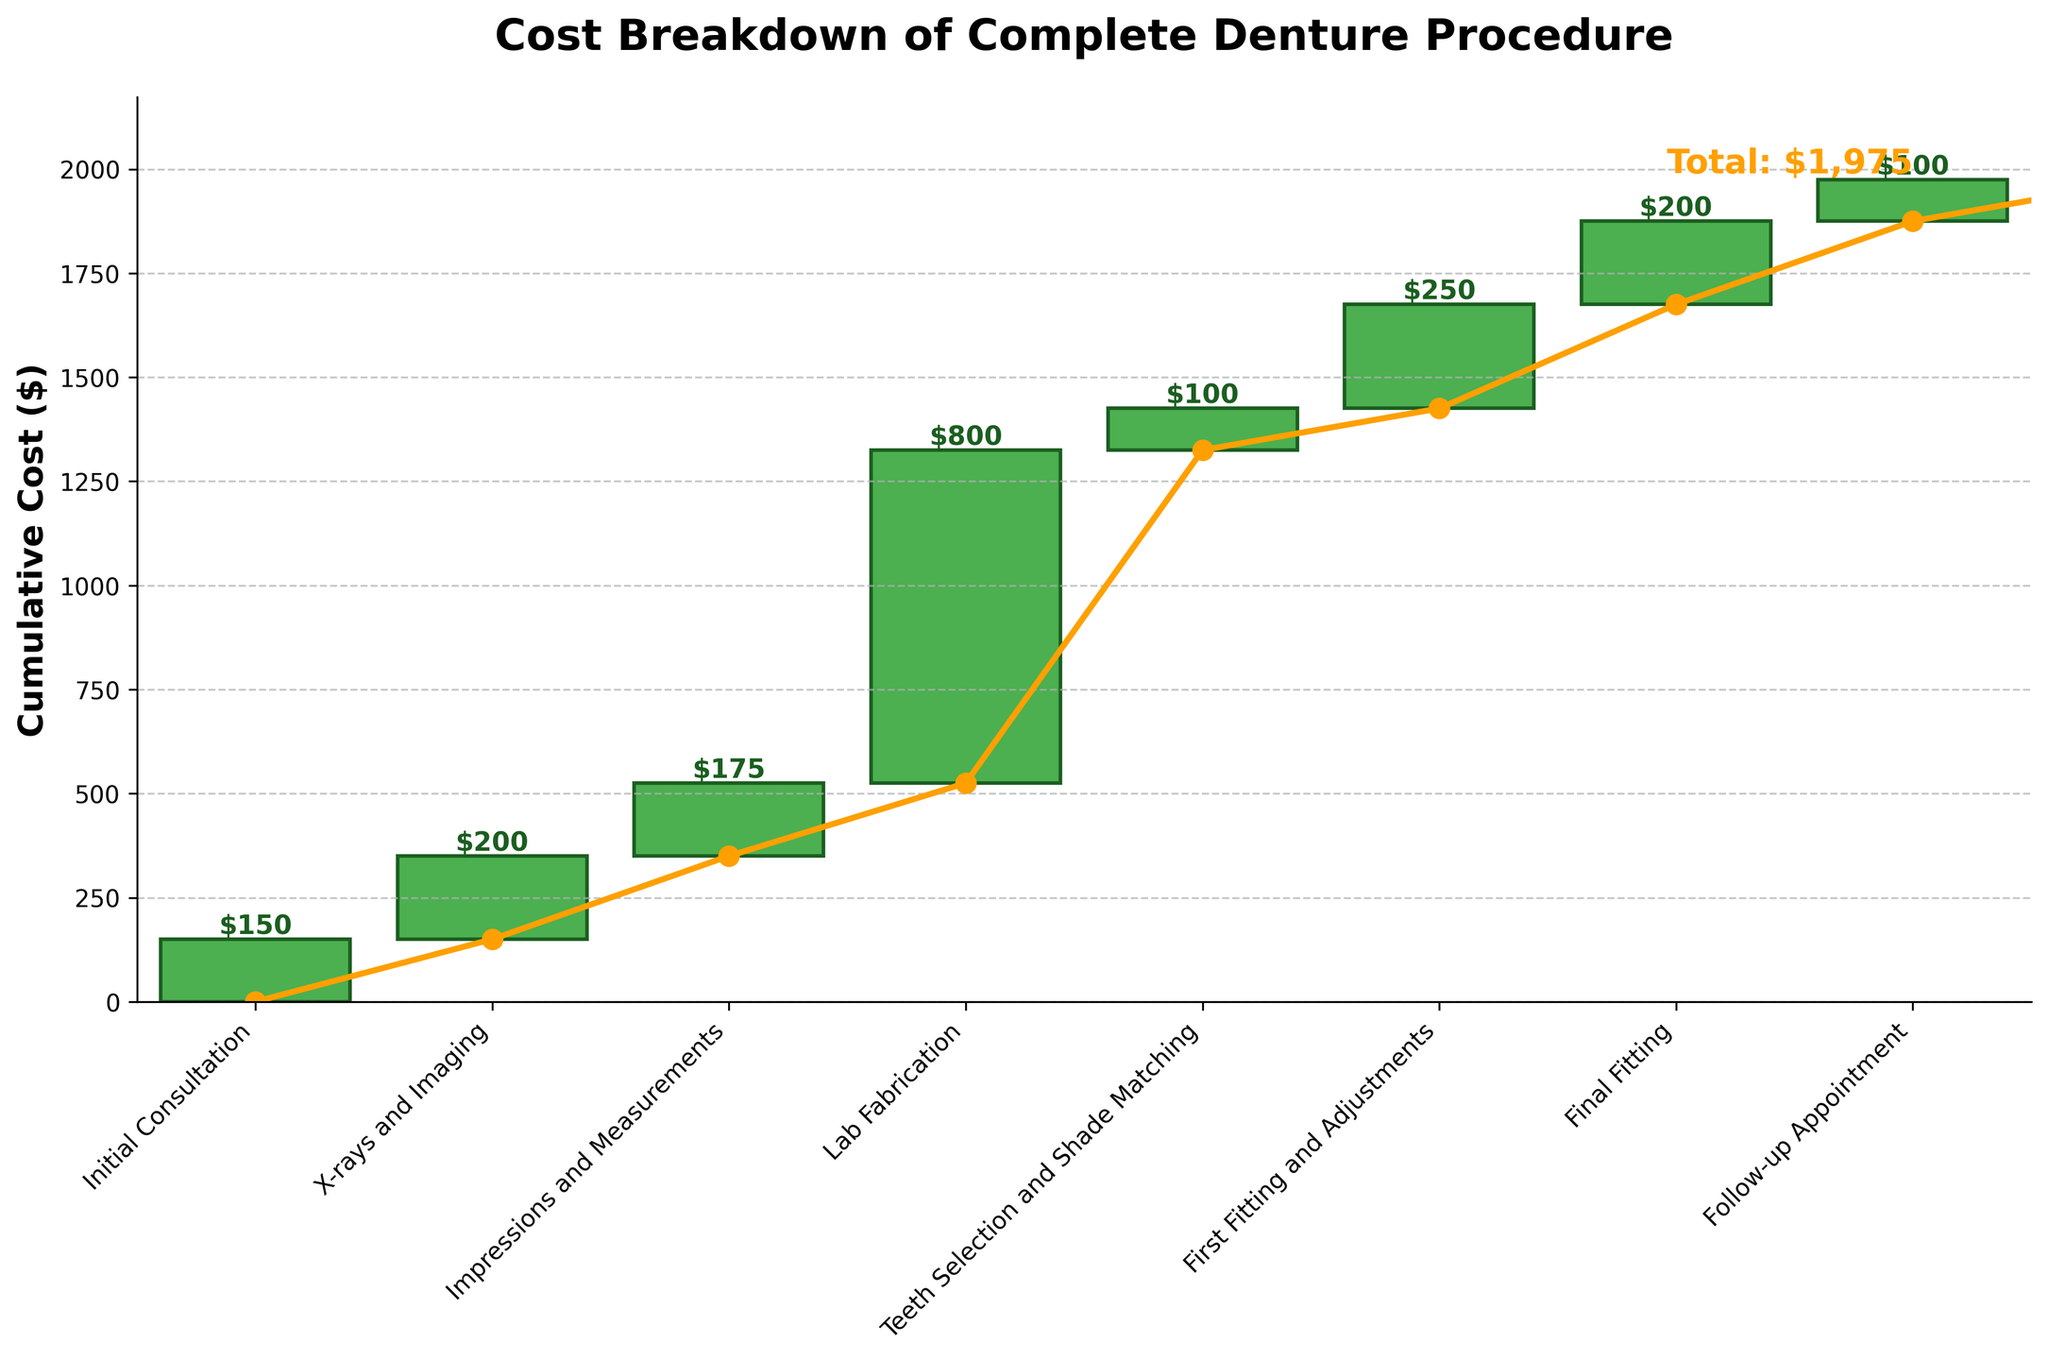What is the title of the chart? The title is written at the top of the chart.
Answer: Cost Breakdown of Complete Denture Procedure What is the cost of the Initial Consultation? The initial consultation is listed as the first step on the x-axis, and its cost is marked above the corresponding bar.
Answer: $150 Which step has the highest individual cost? By examining the heights of the bars, the tallest bar corresponds to the highest individual cost, which is clearly labeled above it.
Answer: Lab Fabrication What is the cumulative cost after the First Fitting and Adjustments? To find this, sum the costs of all steps from the Initial Consultation to the First Fitting and Adjustments. ($150 + $200 + $175 + $800 + $100 + $250)
Answer: $1675 How many steps are included before reaching the Final Fitting? Count the number of steps on the x-axis before the Final Fitting.
Answer: 6 How does the cost of the Final Fitting compare to X-rays and Imaging? Compare the heights of the bars for Final Fitting and X-rays and Imaging. The values are also labeled.
Answer: Final Fitting is equal to X-rays and Imaging; both are $200 What is the combined cost of the Teeth Selection and Shade Matching and the Follow-up Appointment? Add the costs of these two steps. ($100 + $100)
Answer: $200 Which step comes immediately before the Lab Fabrication? Check the label of the step immediately to the left of the Lab Fabrication.
Answer: Impressions and Measurements What is the total cost of the complete denture procedure? Refer to the final cumulative cost, which is usually labeled at the end of the chart.
Answer: $1975 What is the cumulative cost after Impressions and Measurements, but not including Lab Fabrication? Sum the costs up to and including Impressions and Measurements without adding Lab Fabrication. ($150 + $200 + $175)
Answer: $525 